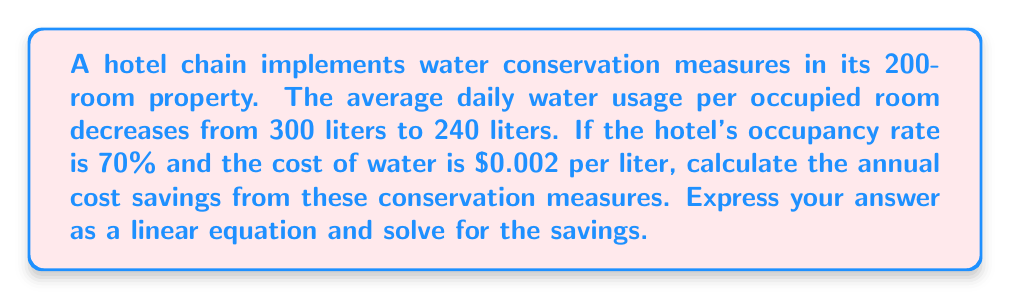Provide a solution to this math problem. Let's approach this step-by-step:

1) First, let's define our variables:
   $x$ = number of days in a year
   $y$ = annual cost savings in dollars

2) We need to calculate the daily water savings:
   Water saved per occupied room = 300 liters - 240 liters = 60 liters

3) Number of occupied rooms per day:
   200 rooms × 70% occupancy = 140 rooms

4) Total daily water savings:
   60 liters × 140 rooms = 8,400 liters

5) Daily cost savings:
   8,400 liters × $0.002/liter = $16.80

6) Now we can set up our linear equation:
   $y = 16.80x$

7) To solve for annual savings, we substitute $x = 365$ (days in a year):
   $y = 16.80 × 365 = $6,132$

Therefore, the linear equation is $y = 16.80x$, and the annual savings is $6,132.
Answer: $y = 16.80x$; $6,132 